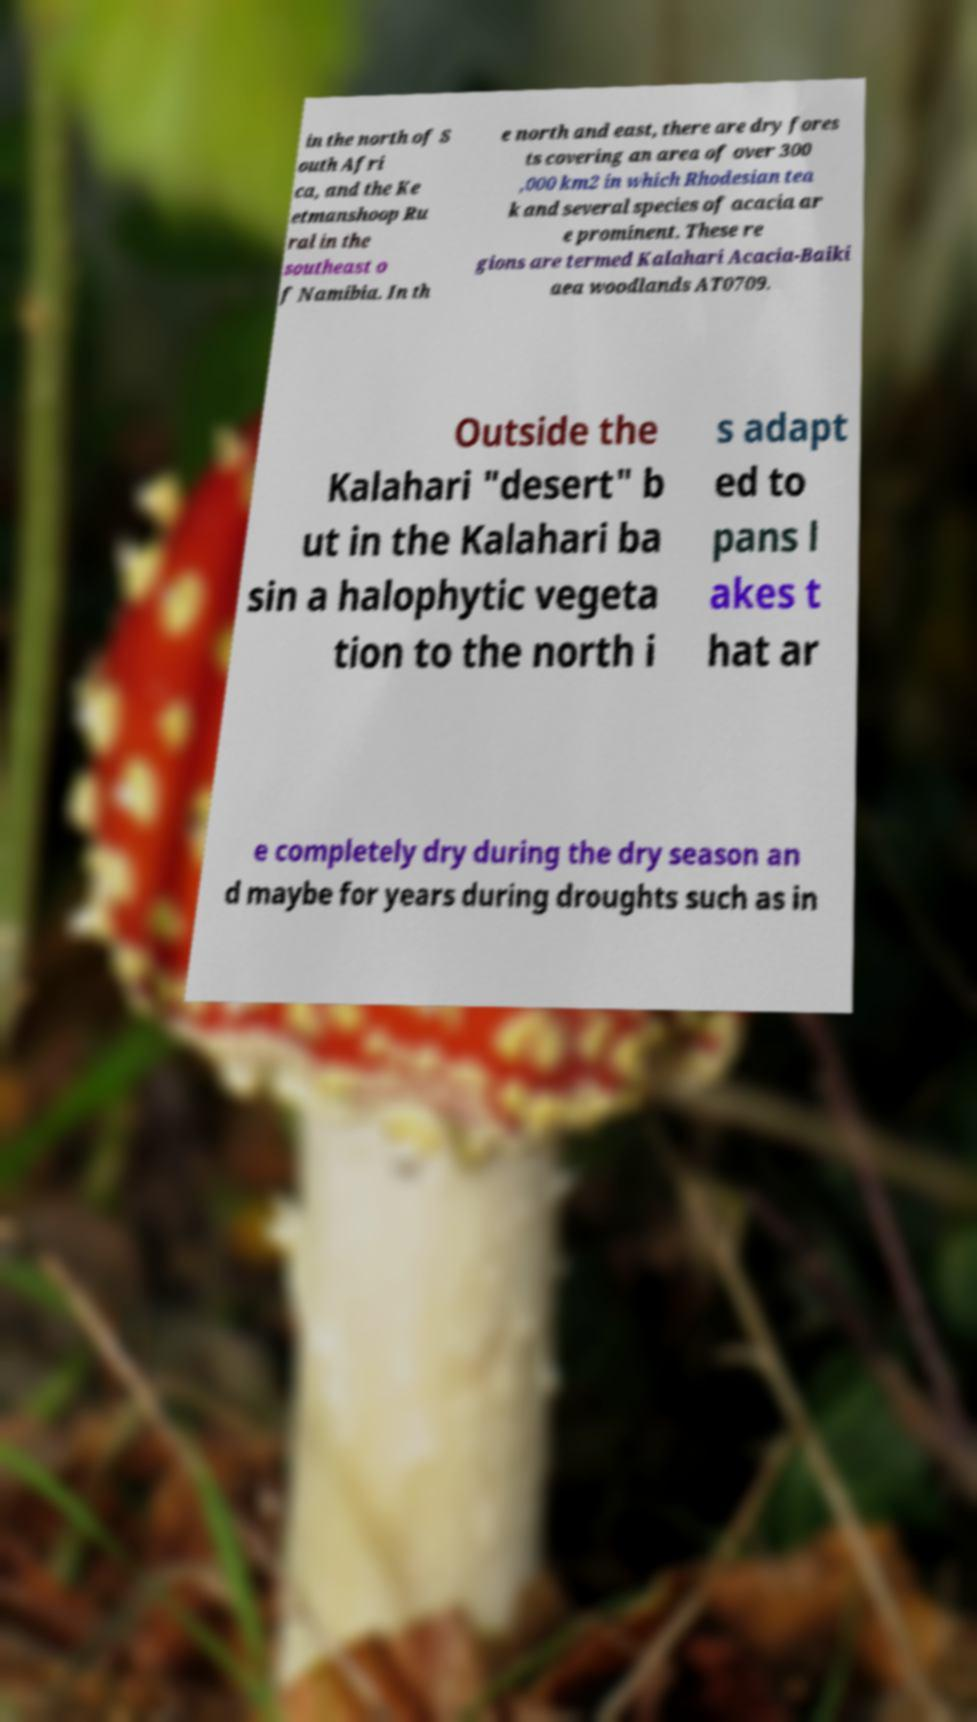There's text embedded in this image that I need extracted. Can you transcribe it verbatim? in the north of S outh Afri ca, and the Ke etmanshoop Ru ral in the southeast o f Namibia. In th e north and east, there are dry fores ts covering an area of over 300 ,000 km2 in which Rhodesian tea k and several species of acacia ar e prominent. These re gions are termed Kalahari Acacia-Baiki aea woodlands AT0709. Outside the Kalahari "desert" b ut in the Kalahari ba sin a halophytic vegeta tion to the north i s adapt ed to pans l akes t hat ar e completely dry during the dry season an d maybe for years during droughts such as in 